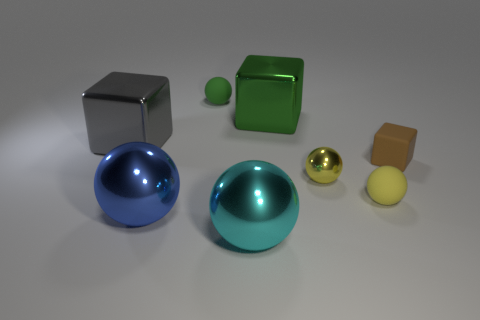Subtract all yellow cylinders. How many yellow spheres are left? 2 Subtract all small brown matte blocks. How many blocks are left? 2 Subtract 2 balls. How many balls are left? 3 Add 2 large cyan metal balls. How many objects exist? 10 Subtract all brown cubes. How many cubes are left? 2 Subtract all spheres. How many objects are left? 3 Subtract all yellow blocks. Subtract all purple cylinders. How many blocks are left? 3 Add 3 green cubes. How many green cubes are left? 4 Add 7 big cyan rubber spheres. How many big cyan rubber spheres exist? 7 Subtract 0 gray balls. How many objects are left? 8 